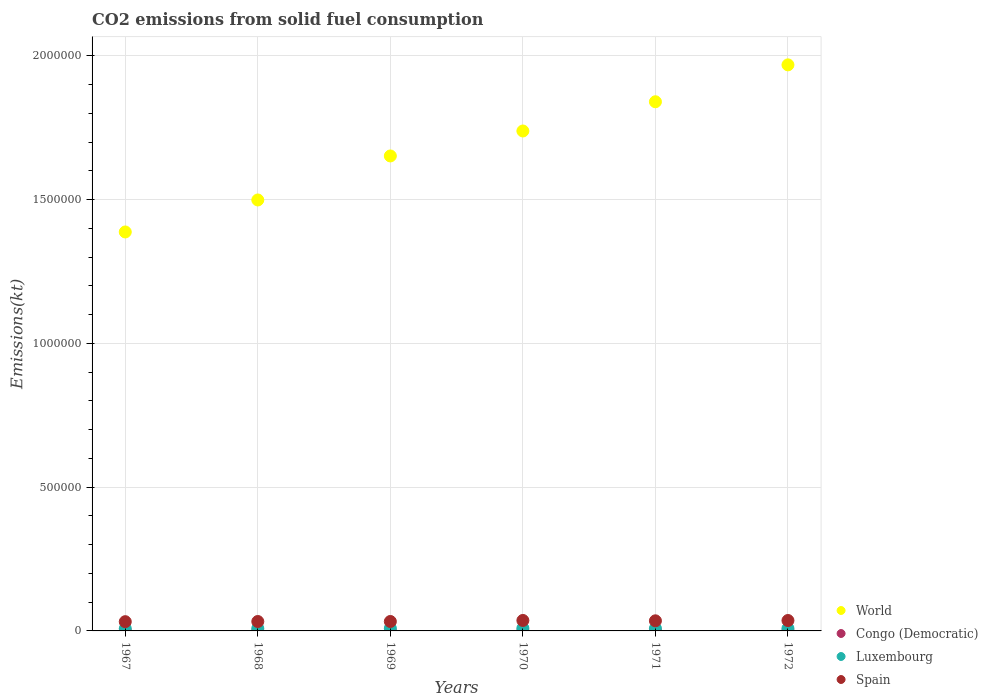How many different coloured dotlines are there?
Ensure brevity in your answer.  4. What is the amount of CO2 emitted in Congo (Democratic) in 1968?
Give a very brief answer. 740.73. Across all years, what is the maximum amount of CO2 emitted in Spain?
Provide a succinct answer. 3.64e+04. Across all years, what is the minimum amount of CO2 emitted in Luxembourg?
Provide a succinct answer. 8122.4. In which year was the amount of CO2 emitted in Congo (Democratic) maximum?
Your answer should be very brief. 1967. In which year was the amount of CO2 emitted in Congo (Democratic) minimum?
Your response must be concise. 1968. What is the total amount of CO2 emitted in Spain in the graph?
Offer a terse response. 2.06e+05. What is the difference between the amount of CO2 emitted in Luxembourg in 1968 and that in 1970?
Keep it short and to the point. -788.4. What is the difference between the amount of CO2 emitted in World in 1971 and the amount of CO2 emitted in Luxembourg in 1970?
Give a very brief answer. 1.83e+06. What is the average amount of CO2 emitted in World per year?
Give a very brief answer. 1.68e+06. In the year 1968, what is the difference between the amount of CO2 emitted in World and amount of CO2 emitted in Spain?
Offer a very short reply. 1.47e+06. What is the ratio of the amount of CO2 emitted in Congo (Democratic) in 1967 to that in 1972?
Provide a succinct answer. 1.12. Is the amount of CO2 emitted in Spain in 1967 less than that in 1969?
Your answer should be very brief. Yes. Is the difference between the amount of CO2 emitted in World in 1968 and 1969 greater than the difference between the amount of CO2 emitted in Spain in 1968 and 1969?
Offer a very short reply. No. What is the difference between the highest and the second highest amount of CO2 emitted in Congo (Democratic)?
Offer a very short reply. 62.34. What is the difference between the highest and the lowest amount of CO2 emitted in Congo (Democratic)?
Your answer should be very brief. 209.02. In how many years, is the amount of CO2 emitted in World greater than the average amount of CO2 emitted in World taken over all years?
Your answer should be very brief. 3. Is it the case that in every year, the sum of the amount of CO2 emitted in Luxembourg and amount of CO2 emitted in World  is greater than the sum of amount of CO2 emitted in Congo (Democratic) and amount of CO2 emitted in Spain?
Make the answer very short. Yes. Is the amount of CO2 emitted in Congo (Democratic) strictly less than the amount of CO2 emitted in Luxembourg over the years?
Ensure brevity in your answer.  Yes. How many dotlines are there?
Offer a terse response. 4. Does the graph contain grids?
Your response must be concise. Yes. How are the legend labels stacked?
Give a very brief answer. Vertical. What is the title of the graph?
Your answer should be compact. CO2 emissions from solid fuel consumption. Does "Nepal" appear as one of the legend labels in the graph?
Your answer should be very brief. No. What is the label or title of the X-axis?
Your answer should be very brief. Years. What is the label or title of the Y-axis?
Offer a very short reply. Emissions(kt). What is the Emissions(kt) in World in 1967?
Provide a short and direct response. 1.39e+06. What is the Emissions(kt) of Congo (Democratic) in 1967?
Keep it short and to the point. 949.75. What is the Emissions(kt) of Luxembourg in 1967?
Your response must be concise. 8122.4. What is the Emissions(kt) of Spain in 1967?
Give a very brief answer. 3.22e+04. What is the Emissions(kt) in World in 1968?
Offer a very short reply. 1.50e+06. What is the Emissions(kt) of Congo (Democratic) in 1968?
Provide a succinct answer. 740.73. What is the Emissions(kt) in Luxembourg in 1968?
Provide a succinct answer. 8705.46. What is the Emissions(kt) of Spain in 1968?
Your response must be concise. 3.28e+04. What is the Emissions(kt) of World in 1969?
Provide a short and direct response. 1.65e+06. What is the Emissions(kt) of Congo (Democratic) in 1969?
Your answer should be compact. 887.41. What is the Emissions(kt) of Luxembourg in 1969?
Give a very brief answer. 9255.51. What is the Emissions(kt) in Spain in 1969?
Give a very brief answer. 3.28e+04. What is the Emissions(kt) in World in 1970?
Offer a very short reply. 1.74e+06. What is the Emissions(kt) in Congo (Democratic) in 1970?
Provide a short and direct response. 788.4. What is the Emissions(kt) in Luxembourg in 1970?
Give a very brief answer. 9493.86. What is the Emissions(kt) of Spain in 1970?
Offer a terse response. 3.64e+04. What is the Emissions(kt) of World in 1971?
Offer a terse response. 1.84e+06. What is the Emissions(kt) in Congo (Democratic) in 1971?
Ensure brevity in your answer.  876.41. What is the Emissions(kt) of Luxembourg in 1971?
Make the answer very short. 8800.8. What is the Emissions(kt) of Spain in 1971?
Your answer should be very brief. 3.52e+04. What is the Emissions(kt) in World in 1972?
Give a very brief answer. 1.97e+06. What is the Emissions(kt) in Congo (Democratic) in 1972?
Your response must be concise. 850.74. What is the Emissions(kt) of Luxembourg in 1972?
Give a very brief answer. 8676.12. What is the Emissions(kt) of Spain in 1972?
Ensure brevity in your answer.  3.62e+04. Across all years, what is the maximum Emissions(kt) of World?
Keep it short and to the point. 1.97e+06. Across all years, what is the maximum Emissions(kt) in Congo (Democratic)?
Give a very brief answer. 949.75. Across all years, what is the maximum Emissions(kt) in Luxembourg?
Offer a terse response. 9493.86. Across all years, what is the maximum Emissions(kt) in Spain?
Give a very brief answer. 3.64e+04. Across all years, what is the minimum Emissions(kt) in World?
Offer a terse response. 1.39e+06. Across all years, what is the minimum Emissions(kt) in Congo (Democratic)?
Offer a very short reply. 740.73. Across all years, what is the minimum Emissions(kt) of Luxembourg?
Offer a very short reply. 8122.4. Across all years, what is the minimum Emissions(kt) of Spain?
Offer a terse response. 3.22e+04. What is the total Emissions(kt) in World in the graph?
Your response must be concise. 1.01e+07. What is the total Emissions(kt) of Congo (Democratic) in the graph?
Keep it short and to the point. 5093.46. What is the total Emissions(kt) in Luxembourg in the graph?
Give a very brief answer. 5.31e+04. What is the total Emissions(kt) in Spain in the graph?
Your answer should be very brief. 2.06e+05. What is the difference between the Emissions(kt) of World in 1967 and that in 1968?
Make the answer very short. -1.11e+05. What is the difference between the Emissions(kt) of Congo (Democratic) in 1967 and that in 1968?
Your response must be concise. 209.02. What is the difference between the Emissions(kt) in Luxembourg in 1967 and that in 1968?
Your response must be concise. -583.05. What is the difference between the Emissions(kt) in Spain in 1967 and that in 1968?
Make the answer very short. -594.05. What is the difference between the Emissions(kt) in World in 1967 and that in 1969?
Your answer should be compact. -2.64e+05. What is the difference between the Emissions(kt) in Congo (Democratic) in 1967 and that in 1969?
Provide a short and direct response. 62.34. What is the difference between the Emissions(kt) in Luxembourg in 1967 and that in 1969?
Offer a terse response. -1133.1. What is the difference between the Emissions(kt) in Spain in 1967 and that in 1969?
Make the answer very short. -656.39. What is the difference between the Emissions(kt) of World in 1967 and that in 1970?
Your response must be concise. -3.51e+05. What is the difference between the Emissions(kt) of Congo (Democratic) in 1967 and that in 1970?
Keep it short and to the point. 161.35. What is the difference between the Emissions(kt) in Luxembourg in 1967 and that in 1970?
Keep it short and to the point. -1371.46. What is the difference between the Emissions(kt) of Spain in 1967 and that in 1970?
Keep it short and to the point. -4242.72. What is the difference between the Emissions(kt) in World in 1967 and that in 1971?
Make the answer very short. -4.53e+05. What is the difference between the Emissions(kt) in Congo (Democratic) in 1967 and that in 1971?
Provide a short and direct response. 73.34. What is the difference between the Emissions(kt) in Luxembourg in 1967 and that in 1971?
Offer a very short reply. -678.39. What is the difference between the Emissions(kt) of Spain in 1967 and that in 1971?
Offer a terse response. -2992.27. What is the difference between the Emissions(kt) in World in 1967 and that in 1972?
Ensure brevity in your answer.  -5.81e+05. What is the difference between the Emissions(kt) of Congo (Democratic) in 1967 and that in 1972?
Make the answer very short. 99.01. What is the difference between the Emissions(kt) in Luxembourg in 1967 and that in 1972?
Provide a short and direct response. -553.72. What is the difference between the Emissions(kt) in Spain in 1967 and that in 1972?
Provide a succinct answer. -4048.37. What is the difference between the Emissions(kt) in World in 1968 and that in 1969?
Your answer should be compact. -1.53e+05. What is the difference between the Emissions(kt) in Congo (Democratic) in 1968 and that in 1969?
Provide a short and direct response. -146.68. What is the difference between the Emissions(kt) in Luxembourg in 1968 and that in 1969?
Provide a succinct answer. -550.05. What is the difference between the Emissions(kt) of Spain in 1968 and that in 1969?
Offer a terse response. -62.34. What is the difference between the Emissions(kt) of World in 1968 and that in 1970?
Ensure brevity in your answer.  -2.40e+05. What is the difference between the Emissions(kt) in Congo (Democratic) in 1968 and that in 1970?
Your answer should be compact. -47.67. What is the difference between the Emissions(kt) in Luxembourg in 1968 and that in 1970?
Provide a succinct answer. -788.4. What is the difference between the Emissions(kt) in Spain in 1968 and that in 1970?
Provide a succinct answer. -3648.66. What is the difference between the Emissions(kt) in World in 1968 and that in 1971?
Keep it short and to the point. -3.42e+05. What is the difference between the Emissions(kt) of Congo (Democratic) in 1968 and that in 1971?
Provide a short and direct response. -135.68. What is the difference between the Emissions(kt) in Luxembourg in 1968 and that in 1971?
Provide a short and direct response. -95.34. What is the difference between the Emissions(kt) in Spain in 1968 and that in 1971?
Offer a very short reply. -2398.22. What is the difference between the Emissions(kt) in World in 1968 and that in 1972?
Ensure brevity in your answer.  -4.70e+05. What is the difference between the Emissions(kt) of Congo (Democratic) in 1968 and that in 1972?
Your answer should be compact. -110.01. What is the difference between the Emissions(kt) in Luxembourg in 1968 and that in 1972?
Make the answer very short. 29.34. What is the difference between the Emissions(kt) of Spain in 1968 and that in 1972?
Make the answer very short. -3454.31. What is the difference between the Emissions(kt) in World in 1969 and that in 1970?
Make the answer very short. -8.68e+04. What is the difference between the Emissions(kt) in Congo (Democratic) in 1969 and that in 1970?
Keep it short and to the point. 99.01. What is the difference between the Emissions(kt) in Luxembourg in 1969 and that in 1970?
Keep it short and to the point. -238.35. What is the difference between the Emissions(kt) of Spain in 1969 and that in 1970?
Provide a short and direct response. -3586.33. What is the difference between the Emissions(kt) of World in 1969 and that in 1971?
Your answer should be very brief. -1.88e+05. What is the difference between the Emissions(kt) in Congo (Democratic) in 1969 and that in 1971?
Provide a short and direct response. 11. What is the difference between the Emissions(kt) of Luxembourg in 1969 and that in 1971?
Give a very brief answer. 454.71. What is the difference between the Emissions(kt) of Spain in 1969 and that in 1971?
Provide a short and direct response. -2335.88. What is the difference between the Emissions(kt) in World in 1969 and that in 1972?
Your response must be concise. -3.17e+05. What is the difference between the Emissions(kt) in Congo (Democratic) in 1969 and that in 1972?
Keep it short and to the point. 36.67. What is the difference between the Emissions(kt) of Luxembourg in 1969 and that in 1972?
Keep it short and to the point. 579.39. What is the difference between the Emissions(kt) in Spain in 1969 and that in 1972?
Your answer should be very brief. -3391.97. What is the difference between the Emissions(kt) in World in 1970 and that in 1971?
Your answer should be compact. -1.02e+05. What is the difference between the Emissions(kt) in Congo (Democratic) in 1970 and that in 1971?
Provide a succinct answer. -88.01. What is the difference between the Emissions(kt) of Luxembourg in 1970 and that in 1971?
Offer a terse response. 693.06. What is the difference between the Emissions(kt) of Spain in 1970 and that in 1971?
Your answer should be very brief. 1250.45. What is the difference between the Emissions(kt) of World in 1970 and that in 1972?
Provide a succinct answer. -2.30e+05. What is the difference between the Emissions(kt) in Congo (Democratic) in 1970 and that in 1972?
Offer a very short reply. -62.34. What is the difference between the Emissions(kt) in Luxembourg in 1970 and that in 1972?
Keep it short and to the point. 817.74. What is the difference between the Emissions(kt) in Spain in 1970 and that in 1972?
Offer a terse response. 194.35. What is the difference between the Emissions(kt) of World in 1971 and that in 1972?
Give a very brief answer. -1.28e+05. What is the difference between the Emissions(kt) of Congo (Democratic) in 1971 and that in 1972?
Offer a very short reply. 25.67. What is the difference between the Emissions(kt) of Luxembourg in 1971 and that in 1972?
Provide a succinct answer. 124.68. What is the difference between the Emissions(kt) of Spain in 1971 and that in 1972?
Give a very brief answer. -1056.1. What is the difference between the Emissions(kt) in World in 1967 and the Emissions(kt) in Congo (Democratic) in 1968?
Give a very brief answer. 1.39e+06. What is the difference between the Emissions(kt) of World in 1967 and the Emissions(kt) of Luxembourg in 1968?
Ensure brevity in your answer.  1.38e+06. What is the difference between the Emissions(kt) of World in 1967 and the Emissions(kt) of Spain in 1968?
Your response must be concise. 1.35e+06. What is the difference between the Emissions(kt) of Congo (Democratic) in 1967 and the Emissions(kt) of Luxembourg in 1968?
Provide a short and direct response. -7755.7. What is the difference between the Emissions(kt) of Congo (Democratic) in 1967 and the Emissions(kt) of Spain in 1968?
Make the answer very short. -3.18e+04. What is the difference between the Emissions(kt) of Luxembourg in 1967 and the Emissions(kt) of Spain in 1968?
Offer a very short reply. -2.46e+04. What is the difference between the Emissions(kt) in World in 1967 and the Emissions(kt) in Congo (Democratic) in 1969?
Offer a very short reply. 1.39e+06. What is the difference between the Emissions(kt) of World in 1967 and the Emissions(kt) of Luxembourg in 1969?
Make the answer very short. 1.38e+06. What is the difference between the Emissions(kt) of World in 1967 and the Emissions(kt) of Spain in 1969?
Offer a terse response. 1.35e+06. What is the difference between the Emissions(kt) of Congo (Democratic) in 1967 and the Emissions(kt) of Luxembourg in 1969?
Offer a terse response. -8305.75. What is the difference between the Emissions(kt) in Congo (Democratic) in 1967 and the Emissions(kt) in Spain in 1969?
Provide a succinct answer. -3.19e+04. What is the difference between the Emissions(kt) of Luxembourg in 1967 and the Emissions(kt) of Spain in 1969?
Your answer should be very brief. -2.47e+04. What is the difference between the Emissions(kt) in World in 1967 and the Emissions(kt) in Congo (Democratic) in 1970?
Offer a very short reply. 1.39e+06. What is the difference between the Emissions(kt) of World in 1967 and the Emissions(kt) of Luxembourg in 1970?
Your answer should be compact. 1.38e+06. What is the difference between the Emissions(kt) of World in 1967 and the Emissions(kt) of Spain in 1970?
Provide a succinct answer. 1.35e+06. What is the difference between the Emissions(kt) of Congo (Democratic) in 1967 and the Emissions(kt) of Luxembourg in 1970?
Offer a very short reply. -8544.11. What is the difference between the Emissions(kt) in Congo (Democratic) in 1967 and the Emissions(kt) in Spain in 1970?
Your answer should be very brief. -3.55e+04. What is the difference between the Emissions(kt) in Luxembourg in 1967 and the Emissions(kt) in Spain in 1970?
Your answer should be very brief. -2.83e+04. What is the difference between the Emissions(kt) of World in 1967 and the Emissions(kt) of Congo (Democratic) in 1971?
Give a very brief answer. 1.39e+06. What is the difference between the Emissions(kt) of World in 1967 and the Emissions(kt) of Luxembourg in 1971?
Provide a succinct answer. 1.38e+06. What is the difference between the Emissions(kt) in World in 1967 and the Emissions(kt) in Spain in 1971?
Offer a very short reply. 1.35e+06. What is the difference between the Emissions(kt) in Congo (Democratic) in 1967 and the Emissions(kt) in Luxembourg in 1971?
Offer a terse response. -7851.05. What is the difference between the Emissions(kt) in Congo (Democratic) in 1967 and the Emissions(kt) in Spain in 1971?
Provide a short and direct response. -3.42e+04. What is the difference between the Emissions(kt) of Luxembourg in 1967 and the Emissions(kt) of Spain in 1971?
Make the answer very short. -2.70e+04. What is the difference between the Emissions(kt) of World in 1967 and the Emissions(kt) of Congo (Democratic) in 1972?
Offer a very short reply. 1.39e+06. What is the difference between the Emissions(kt) of World in 1967 and the Emissions(kt) of Luxembourg in 1972?
Provide a short and direct response. 1.38e+06. What is the difference between the Emissions(kt) in World in 1967 and the Emissions(kt) in Spain in 1972?
Provide a succinct answer. 1.35e+06. What is the difference between the Emissions(kt) of Congo (Democratic) in 1967 and the Emissions(kt) of Luxembourg in 1972?
Your answer should be compact. -7726.37. What is the difference between the Emissions(kt) in Congo (Democratic) in 1967 and the Emissions(kt) in Spain in 1972?
Provide a succinct answer. -3.53e+04. What is the difference between the Emissions(kt) of Luxembourg in 1967 and the Emissions(kt) of Spain in 1972?
Make the answer very short. -2.81e+04. What is the difference between the Emissions(kt) of World in 1968 and the Emissions(kt) of Congo (Democratic) in 1969?
Offer a terse response. 1.50e+06. What is the difference between the Emissions(kt) in World in 1968 and the Emissions(kt) in Luxembourg in 1969?
Your response must be concise. 1.49e+06. What is the difference between the Emissions(kt) in World in 1968 and the Emissions(kt) in Spain in 1969?
Your response must be concise. 1.47e+06. What is the difference between the Emissions(kt) in Congo (Democratic) in 1968 and the Emissions(kt) in Luxembourg in 1969?
Your response must be concise. -8514.77. What is the difference between the Emissions(kt) in Congo (Democratic) in 1968 and the Emissions(kt) in Spain in 1969?
Make the answer very short. -3.21e+04. What is the difference between the Emissions(kt) in Luxembourg in 1968 and the Emissions(kt) in Spain in 1969?
Provide a succinct answer. -2.41e+04. What is the difference between the Emissions(kt) in World in 1968 and the Emissions(kt) in Congo (Democratic) in 1970?
Keep it short and to the point. 1.50e+06. What is the difference between the Emissions(kt) in World in 1968 and the Emissions(kt) in Luxembourg in 1970?
Offer a very short reply. 1.49e+06. What is the difference between the Emissions(kt) in World in 1968 and the Emissions(kt) in Spain in 1970?
Provide a short and direct response. 1.46e+06. What is the difference between the Emissions(kt) of Congo (Democratic) in 1968 and the Emissions(kt) of Luxembourg in 1970?
Your answer should be compact. -8753.13. What is the difference between the Emissions(kt) in Congo (Democratic) in 1968 and the Emissions(kt) in Spain in 1970?
Provide a short and direct response. -3.57e+04. What is the difference between the Emissions(kt) of Luxembourg in 1968 and the Emissions(kt) of Spain in 1970?
Give a very brief answer. -2.77e+04. What is the difference between the Emissions(kt) of World in 1968 and the Emissions(kt) of Congo (Democratic) in 1971?
Make the answer very short. 1.50e+06. What is the difference between the Emissions(kt) of World in 1968 and the Emissions(kt) of Luxembourg in 1971?
Provide a succinct answer. 1.49e+06. What is the difference between the Emissions(kt) of World in 1968 and the Emissions(kt) of Spain in 1971?
Offer a terse response. 1.46e+06. What is the difference between the Emissions(kt) in Congo (Democratic) in 1968 and the Emissions(kt) in Luxembourg in 1971?
Your response must be concise. -8060.07. What is the difference between the Emissions(kt) of Congo (Democratic) in 1968 and the Emissions(kt) of Spain in 1971?
Your answer should be very brief. -3.44e+04. What is the difference between the Emissions(kt) of Luxembourg in 1968 and the Emissions(kt) of Spain in 1971?
Make the answer very short. -2.65e+04. What is the difference between the Emissions(kt) of World in 1968 and the Emissions(kt) of Congo (Democratic) in 1972?
Provide a short and direct response. 1.50e+06. What is the difference between the Emissions(kt) in World in 1968 and the Emissions(kt) in Luxembourg in 1972?
Your response must be concise. 1.49e+06. What is the difference between the Emissions(kt) of World in 1968 and the Emissions(kt) of Spain in 1972?
Offer a terse response. 1.46e+06. What is the difference between the Emissions(kt) of Congo (Democratic) in 1968 and the Emissions(kt) of Luxembourg in 1972?
Your answer should be very brief. -7935.39. What is the difference between the Emissions(kt) in Congo (Democratic) in 1968 and the Emissions(kt) in Spain in 1972?
Offer a terse response. -3.55e+04. What is the difference between the Emissions(kt) of Luxembourg in 1968 and the Emissions(kt) of Spain in 1972?
Your answer should be compact. -2.75e+04. What is the difference between the Emissions(kt) of World in 1969 and the Emissions(kt) of Congo (Democratic) in 1970?
Your answer should be very brief. 1.65e+06. What is the difference between the Emissions(kt) in World in 1969 and the Emissions(kt) in Luxembourg in 1970?
Your answer should be very brief. 1.64e+06. What is the difference between the Emissions(kt) in World in 1969 and the Emissions(kt) in Spain in 1970?
Provide a short and direct response. 1.62e+06. What is the difference between the Emissions(kt) of Congo (Democratic) in 1969 and the Emissions(kt) of Luxembourg in 1970?
Offer a very short reply. -8606.45. What is the difference between the Emissions(kt) in Congo (Democratic) in 1969 and the Emissions(kt) in Spain in 1970?
Provide a succinct answer. -3.55e+04. What is the difference between the Emissions(kt) of Luxembourg in 1969 and the Emissions(kt) of Spain in 1970?
Offer a terse response. -2.72e+04. What is the difference between the Emissions(kt) of World in 1969 and the Emissions(kt) of Congo (Democratic) in 1971?
Your answer should be compact. 1.65e+06. What is the difference between the Emissions(kt) in World in 1969 and the Emissions(kt) in Luxembourg in 1971?
Provide a succinct answer. 1.64e+06. What is the difference between the Emissions(kt) in World in 1969 and the Emissions(kt) in Spain in 1971?
Your answer should be compact. 1.62e+06. What is the difference between the Emissions(kt) in Congo (Democratic) in 1969 and the Emissions(kt) in Luxembourg in 1971?
Make the answer very short. -7913.39. What is the difference between the Emissions(kt) in Congo (Democratic) in 1969 and the Emissions(kt) in Spain in 1971?
Ensure brevity in your answer.  -3.43e+04. What is the difference between the Emissions(kt) of Luxembourg in 1969 and the Emissions(kt) of Spain in 1971?
Keep it short and to the point. -2.59e+04. What is the difference between the Emissions(kt) in World in 1969 and the Emissions(kt) in Congo (Democratic) in 1972?
Keep it short and to the point. 1.65e+06. What is the difference between the Emissions(kt) in World in 1969 and the Emissions(kt) in Luxembourg in 1972?
Offer a terse response. 1.64e+06. What is the difference between the Emissions(kt) in World in 1969 and the Emissions(kt) in Spain in 1972?
Your answer should be compact. 1.62e+06. What is the difference between the Emissions(kt) of Congo (Democratic) in 1969 and the Emissions(kt) of Luxembourg in 1972?
Give a very brief answer. -7788.71. What is the difference between the Emissions(kt) of Congo (Democratic) in 1969 and the Emissions(kt) of Spain in 1972?
Provide a succinct answer. -3.53e+04. What is the difference between the Emissions(kt) of Luxembourg in 1969 and the Emissions(kt) of Spain in 1972?
Ensure brevity in your answer.  -2.70e+04. What is the difference between the Emissions(kt) of World in 1970 and the Emissions(kt) of Congo (Democratic) in 1971?
Make the answer very short. 1.74e+06. What is the difference between the Emissions(kt) in World in 1970 and the Emissions(kt) in Luxembourg in 1971?
Ensure brevity in your answer.  1.73e+06. What is the difference between the Emissions(kt) of World in 1970 and the Emissions(kt) of Spain in 1971?
Your answer should be compact. 1.70e+06. What is the difference between the Emissions(kt) of Congo (Democratic) in 1970 and the Emissions(kt) of Luxembourg in 1971?
Your answer should be compact. -8012.4. What is the difference between the Emissions(kt) of Congo (Democratic) in 1970 and the Emissions(kt) of Spain in 1971?
Make the answer very short. -3.44e+04. What is the difference between the Emissions(kt) of Luxembourg in 1970 and the Emissions(kt) of Spain in 1971?
Your answer should be very brief. -2.57e+04. What is the difference between the Emissions(kt) of World in 1970 and the Emissions(kt) of Congo (Democratic) in 1972?
Offer a terse response. 1.74e+06. What is the difference between the Emissions(kt) of World in 1970 and the Emissions(kt) of Luxembourg in 1972?
Keep it short and to the point. 1.73e+06. What is the difference between the Emissions(kt) in World in 1970 and the Emissions(kt) in Spain in 1972?
Provide a short and direct response. 1.70e+06. What is the difference between the Emissions(kt) in Congo (Democratic) in 1970 and the Emissions(kt) in Luxembourg in 1972?
Offer a terse response. -7887.72. What is the difference between the Emissions(kt) of Congo (Democratic) in 1970 and the Emissions(kt) of Spain in 1972?
Offer a very short reply. -3.54e+04. What is the difference between the Emissions(kt) in Luxembourg in 1970 and the Emissions(kt) in Spain in 1972?
Provide a succinct answer. -2.67e+04. What is the difference between the Emissions(kt) in World in 1971 and the Emissions(kt) in Congo (Democratic) in 1972?
Provide a short and direct response. 1.84e+06. What is the difference between the Emissions(kt) of World in 1971 and the Emissions(kt) of Luxembourg in 1972?
Provide a succinct answer. 1.83e+06. What is the difference between the Emissions(kt) in World in 1971 and the Emissions(kt) in Spain in 1972?
Offer a very short reply. 1.80e+06. What is the difference between the Emissions(kt) in Congo (Democratic) in 1971 and the Emissions(kt) in Luxembourg in 1972?
Keep it short and to the point. -7799.71. What is the difference between the Emissions(kt) of Congo (Democratic) in 1971 and the Emissions(kt) of Spain in 1972?
Offer a very short reply. -3.53e+04. What is the difference between the Emissions(kt) in Luxembourg in 1971 and the Emissions(kt) in Spain in 1972?
Ensure brevity in your answer.  -2.74e+04. What is the average Emissions(kt) of World per year?
Give a very brief answer. 1.68e+06. What is the average Emissions(kt) in Congo (Democratic) per year?
Offer a terse response. 848.91. What is the average Emissions(kt) in Luxembourg per year?
Make the answer very short. 8842.36. What is the average Emissions(kt) of Spain per year?
Ensure brevity in your answer.  3.43e+04. In the year 1967, what is the difference between the Emissions(kt) of World and Emissions(kt) of Congo (Democratic)?
Provide a short and direct response. 1.39e+06. In the year 1967, what is the difference between the Emissions(kt) of World and Emissions(kt) of Luxembourg?
Your response must be concise. 1.38e+06. In the year 1967, what is the difference between the Emissions(kt) in World and Emissions(kt) in Spain?
Offer a terse response. 1.36e+06. In the year 1967, what is the difference between the Emissions(kt) in Congo (Democratic) and Emissions(kt) in Luxembourg?
Keep it short and to the point. -7172.65. In the year 1967, what is the difference between the Emissions(kt) in Congo (Democratic) and Emissions(kt) in Spain?
Make the answer very short. -3.12e+04. In the year 1967, what is the difference between the Emissions(kt) of Luxembourg and Emissions(kt) of Spain?
Your response must be concise. -2.40e+04. In the year 1968, what is the difference between the Emissions(kt) in World and Emissions(kt) in Congo (Democratic)?
Provide a succinct answer. 1.50e+06. In the year 1968, what is the difference between the Emissions(kt) in World and Emissions(kt) in Luxembourg?
Provide a succinct answer. 1.49e+06. In the year 1968, what is the difference between the Emissions(kt) of World and Emissions(kt) of Spain?
Your answer should be compact. 1.47e+06. In the year 1968, what is the difference between the Emissions(kt) in Congo (Democratic) and Emissions(kt) in Luxembourg?
Ensure brevity in your answer.  -7964.72. In the year 1968, what is the difference between the Emissions(kt) of Congo (Democratic) and Emissions(kt) of Spain?
Make the answer very short. -3.20e+04. In the year 1968, what is the difference between the Emissions(kt) in Luxembourg and Emissions(kt) in Spain?
Offer a terse response. -2.41e+04. In the year 1969, what is the difference between the Emissions(kt) of World and Emissions(kt) of Congo (Democratic)?
Your answer should be very brief. 1.65e+06. In the year 1969, what is the difference between the Emissions(kt) in World and Emissions(kt) in Luxembourg?
Your answer should be very brief. 1.64e+06. In the year 1969, what is the difference between the Emissions(kt) of World and Emissions(kt) of Spain?
Your answer should be compact. 1.62e+06. In the year 1969, what is the difference between the Emissions(kt) of Congo (Democratic) and Emissions(kt) of Luxembourg?
Ensure brevity in your answer.  -8368.09. In the year 1969, what is the difference between the Emissions(kt) in Congo (Democratic) and Emissions(kt) in Spain?
Keep it short and to the point. -3.19e+04. In the year 1969, what is the difference between the Emissions(kt) in Luxembourg and Emissions(kt) in Spain?
Keep it short and to the point. -2.36e+04. In the year 1970, what is the difference between the Emissions(kt) of World and Emissions(kt) of Congo (Democratic)?
Keep it short and to the point. 1.74e+06. In the year 1970, what is the difference between the Emissions(kt) of World and Emissions(kt) of Luxembourg?
Provide a short and direct response. 1.73e+06. In the year 1970, what is the difference between the Emissions(kt) in World and Emissions(kt) in Spain?
Keep it short and to the point. 1.70e+06. In the year 1970, what is the difference between the Emissions(kt) of Congo (Democratic) and Emissions(kt) of Luxembourg?
Give a very brief answer. -8705.46. In the year 1970, what is the difference between the Emissions(kt) in Congo (Democratic) and Emissions(kt) in Spain?
Keep it short and to the point. -3.56e+04. In the year 1970, what is the difference between the Emissions(kt) in Luxembourg and Emissions(kt) in Spain?
Offer a very short reply. -2.69e+04. In the year 1971, what is the difference between the Emissions(kt) of World and Emissions(kt) of Congo (Democratic)?
Provide a succinct answer. 1.84e+06. In the year 1971, what is the difference between the Emissions(kt) of World and Emissions(kt) of Luxembourg?
Offer a terse response. 1.83e+06. In the year 1971, what is the difference between the Emissions(kt) of World and Emissions(kt) of Spain?
Give a very brief answer. 1.81e+06. In the year 1971, what is the difference between the Emissions(kt) in Congo (Democratic) and Emissions(kt) in Luxembourg?
Offer a very short reply. -7924.39. In the year 1971, what is the difference between the Emissions(kt) of Congo (Democratic) and Emissions(kt) of Spain?
Keep it short and to the point. -3.43e+04. In the year 1971, what is the difference between the Emissions(kt) in Luxembourg and Emissions(kt) in Spain?
Your response must be concise. -2.64e+04. In the year 1972, what is the difference between the Emissions(kt) in World and Emissions(kt) in Congo (Democratic)?
Make the answer very short. 1.97e+06. In the year 1972, what is the difference between the Emissions(kt) of World and Emissions(kt) of Luxembourg?
Provide a succinct answer. 1.96e+06. In the year 1972, what is the difference between the Emissions(kt) in World and Emissions(kt) in Spain?
Provide a succinct answer. 1.93e+06. In the year 1972, what is the difference between the Emissions(kt) of Congo (Democratic) and Emissions(kt) of Luxembourg?
Your response must be concise. -7825.38. In the year 1972, what is the difference between the Emissions(kt) in Congo (Democratic) and Emissions(kt) in Spain?
Your answer should be very brief. -3.54e+04. In the year 1972, what is the difference between the Emissions(kt) of Luxembourg and Emissions(kt) of Spain?
Your response must be concise. -2.75e+04. What is the ratio of the Emissions(kt) in World in 1967 to that in 1968?
Your answer should be compact. 0.93. What is the ratio of the Emissions(kt) in Congo (Democratic) in 1967 to that in 1968?
Your answer should be very brief. 1.28. What is the ratio of the Emissions(kt) in Luxembourg in 1967 to that in 1968?
Your answer should be very brief. 0.93. What is the ratio of the Emissions(kt) in Spain in 1967 to that in 1968?
Your response must be concise. 0.98. What is the ratio of the Emissions(kt) of World in 1967 to that in 1969?
Your answer should be very brief. 0.84. What is the ratio of the Emissions(kt) in Congo (Democratic) in 1967 to that in 1969?
Provide a short and direct response. 1.07. What is the ratio of the Emissions(kt) in Luxembourg in 1967 to that in 1969?
Offer a terse response. 0.88. What is the ratio of the Emissions(kt) of World in 1967 to that in 1970?
Your answer should be very brief. 0.8. What is the ratio of the Emissions(kt) of Congo (Democratic) in 1967 to that in 1970?
Offer a terse response. 1.2. What is the ratio of the Emissions(kt) in Luxembourg in 1967 to that in 1970?
Offer a very short reply. 0.86. What is the ratio of the Emissions(kt) in Spain in 1967 to that in 1970?
Keep it short and to the point. 0.88. What is the ratio of the Emissions(kt) in World in 1967 to that in 1971?
Your response must be concise. 0.75. What is the ratio of the Emissions(kt) of Congo (Democratic) in 1967 to that in 1971?
Keep it short and to the point. 1.08. What is the ratio of the Emissions(kt) in Luxembourg in 1967 to that in 1971?
Ensure brevity in your answer.  0.92. What is the ratio of the Emissions(kt) of Spain in 1967 to that in 1971?
Provide a succinct answer. 0.91. What is the ratio of the Emissions(kt) in World in 1967 to that in 1972?
Your answer should be compact. 0.7. What is the ratio of the Emissions(kt) of Congo (Democratic) in 1967 to that in 1972?
Provide a short and direct response. 1.12. What is the ratio of the Emissions(kt) in Luxembourg in 1967 to that in 1972?
Offer a very short reply. 0.94. What is the ratio of the Emissions(kt) of Spain in 1967 to that in 1972?
Your answer should be compact. 0.89. What is the ratio of the Emissions(kt) of World in 1968 to that in 1969?
Give a very brief answer. 0.91. What is the ratio of the Emissions(kt) in Congo (Democratic) in 1968 to that in 1969?
Offer a terse response. 0.83. What is the ratio of the Emissions(kt) of Luxembourg in 1968 to that in 1969?
Your answer should be very brief. 0.94. What is the ratio of the Emissions(kt) of World in 1968 to that in 1970?
Your answer should be compact. 0.86. What is the ratio of the Emissions(kt) of Congo (Democratic) in 1968 to that in 1970?
Offer a very short reply. 0.94. What is the ratio of the Emissions(kt) of Luxembourg in 1968 to that in 1970?
Provide a short and direct response. 0.92. What is the ratio of the Emissions(kt) of Spain in 1968 to that in 1970?
Your answer should be compact. 0.9. What is the ratio of the Emissions(kt) of World in 1968 to that in 1971?
Provide a succinct answer. 0.81. What is the ratio of the Emissions(kt) of Congo (Democratic) in 1968 to that in 1971?
Your response must be concise. 0.85. What is the ratio of the Emissions(kt) of Spain in 1968 to that in 1971?
Your response must be concise. 0.93. What is the ratio of the Emissions(kt) of World in 1968 to that in 1972?
Offer a terse response. 0.76. What is the ratio of the Emissions(kt) in Congo (Democratic) in 1968 to that in 1972?
Offer a terse response. 0.87. What is the ratio of the Emissions(kt) in Luxembourg in 1968 to that in 1972?
Offer a terse response. 1. What is the ratio of the Emissions(kt) in Spain in 1968 to that in 1972?
Give a very brief answer. 0.9. What is the ratio of the Emissions(kt) in World in 1969 to that in 1970?
Provide a succinct answer. 0.95. What is the ratio of the Emissions(kt) in Congo (Democratic) in 1969 to that in 1970?
Your answer should be compact. 1.13. What is the ratio of the Emissions(kt) in Luxembourg in 1969 to that in 1970?
Your answer should be very brief. 0.97. What is the ratio of the Emissions(kt) of Spain in 1969 to that in 1970?
Your answer should be very brief. 0.9. What is the ratio of the Emissions(kt) of World in 1969 to that in 1971?
Ensure brevity in your answer.  0.9. What is the ratio of the Emissions(kt) in Congo (Democratic) in 1969 to that in 1971?
Provide a succinct answer. 1.01. What is the ratio of the Emissions(kt) in Luxembourg in 1969 to that in 1971?
Keep it short and to the point. 1.05. What is the ratio of the Emissions(kt) of Spain in 1969 to that in 1971?
Make the answer very short. 0.93. What is the ratio of the Emissions(kt) in World in 1969 to that in 1972?
Your response must be concise. 0.84. What is the ratio of the Emissions(kt) in Congo (Democratic) in 1969 to that in 1972?
Ensure brevity in your answer.  1.04. What is the ratio of the Emissions(kt) of Luxembourg in 1969 to that in 1972?
Offer a very short reply. 1.07. What is the ratio of the Emissions(kt) of Spain in 1969 to that in 1972?
Give a very brief answer. 0.91. What is the ratio of the Emissions(kt) in World in 1970 to that in 1971?
Make the answer very short. 0.94. What is the ratio of the Emissions(kt) in Congo (Democratic) in 1970 to that in 1971?
Provide a short and direct response. 0.9. What is the ratio of the Emissions(kt) in Luxembourg in 1970 to that in 1971?
Provide a short and direct response. 1.08. What is the ratio of the Emissions(kt) in Spain in 1970 to that in 1971?
Keep it short and to the point. 1.04. What is the ratio of the Emissions(kt) of World in 1970 to that in 1972?
Ensure brevity in your answer.  0.88. What is the ratio of the Emissions(kt) of Congo (Democratic) in 1970 to that in 1972?
Provide a short and direct response. 0.93. What is the ratio of the Emissions(kt) of Luxembourg in 1970 to that in 1972?
Keep it short and to the point. 1.09. What is the ratio of the Emissions(kt) of Spain in 1970 to that in 1972?
Give a very brief answer. 1.01. What is the ratio of the Emissions(kt) in World in 1971 to that in 1972?
Provide a succinct answer. 0.93. What is the ratio of the Emissions(kt) in Congo (Democratic) in 1971 to that in 1972?
Ensure brevity in your answer.  1.03. What is the ratio of the Emissions(kt) in Luxembourg in 1971 to that in 1972?
Your answer should be very brief. 1.01. What is the ratio of the Emissions(kt) in Spain in 1971 to that in 1972?
Your response must be concise. 0.97. What is the difference between the highest and the second highest Emissions(kt) in World?
Your response must be concise. 1.28e+05. What is the difference between the highest and the second highest Emissions(kt) in Congo (Democratic)?
Provide a short and direct response. 62.34. What is the difference between the highest and the second highest Emissions(kt) in Luxembourg?
Provide a short and direct response. 238.35. What is the difference between the highest and the second highest Emissions(kt) in Spain?
Provide a short and direct response. 194.35. What is the difference between the highest and the lowest Emissions(kt) in World?
Keep it short and to the point. 5.81e+05. What is the difference between the highest and the lowest Emissions(kt) in Congo (Democratic)?
Your answer should be compact. 209.02. What is the difference between the highest and the lowest Emissions(kt) of Luxembourg?
Give a very brief answer. 1371.46. What is the difference between the highest and the lowest Emissions(kt) in Spain?
Provide a short and direct response. 4242.72. 